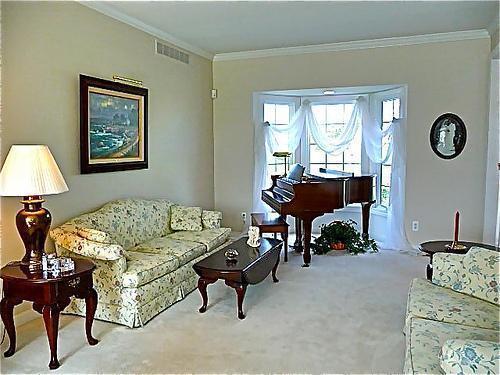How many couches are there?
Give a very brief answer. 2. How many photos are on the walls?
Give a very brief answer. 2. How many couches can be seen?
Give a very brief answer. 2. 